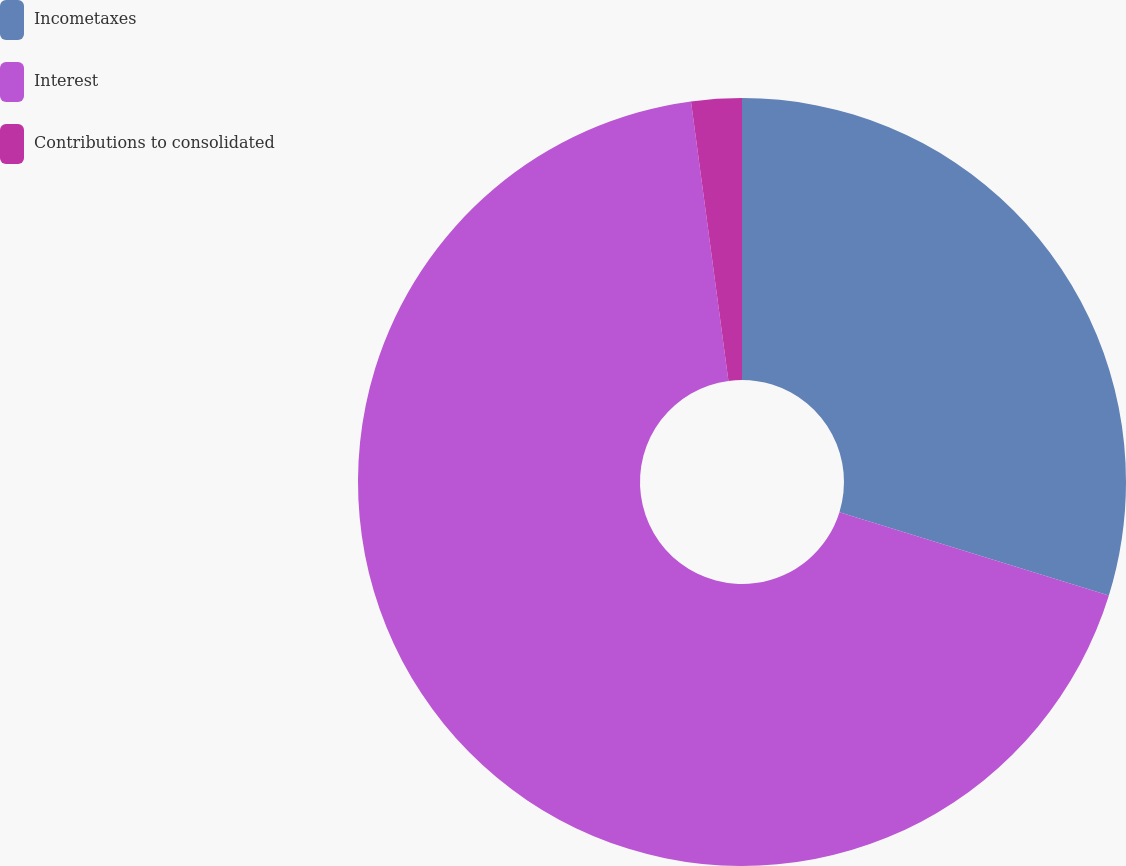<chart> <loc_0><loc_0><loc_500><loc_500><pie_chart><fcel>Incometaxes<fcel>Interest<fcel>Contributions to consolidated<nl><fcel>29.77%<fcel>68.1%<fcel>2.12%<nl></chart> 